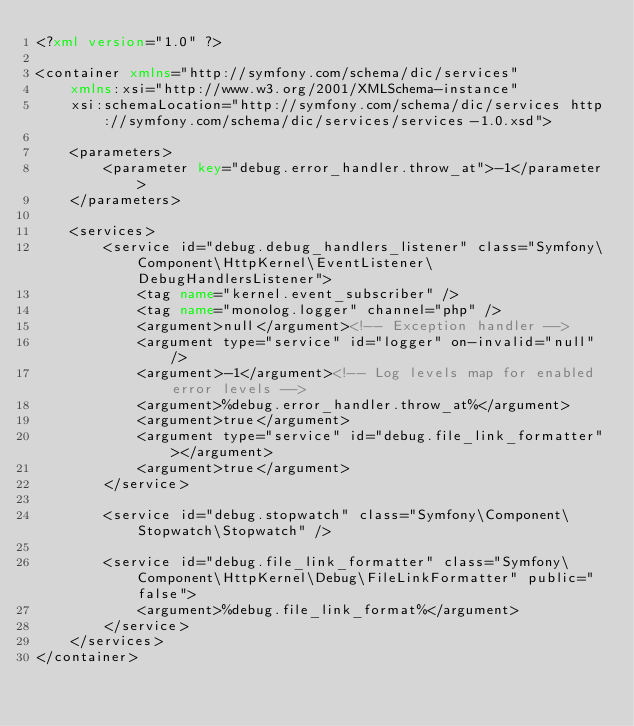<code> <loc_0><loc_0><loc_500><loc_500><_XML_><?xml version="1.0" ?>

<container xmlns="http://symfony.com/schema/dic/services"
    xmlns:xsi="http://www.w3.org/2001/XMLSchema-instance"
    xsi:schemaLocation="http://symfony.com/schema/dic/services http://symfony.com/schema/dic/services/services-1.0.xsd">

    <parameters>
        <parameter key="debug.error_handler.throw_at">-1</parameter>
    </parameters>

    <services>
        <service id="debug.debug_handlers_listener" class="Symfony\Component\HttpKernel\EventListener\DebugHandlersListener">
            <tag name="kernel.event_subscriber" />
            <tag name="monolog.logger" channel="php" />
            <argument>null</argument><!-- Exception handler -->
            <argument type="service" id="logger" on-invalid="null" />
            <argument>-1</argument><!-- Log levels map for enabled error levels -->
            <argument>%debug.error_handler.throw_at%</argument>
            <argument>true</argument>
            <argument type="service" id="debug.file_link_formatter"></argument>
            <argument>true</argument>
        </service>

        <service id="debug.stopwatch" class="Symfony\Component\Stopwatch\Stopwatch" />

        <service id="debug.file_link_formatter" class="Symfony\Component\HttpKernel\Debug\FileLinkFormatter" public="false">
            <argument>%debug.file_link_format%</argument>
        </service>
    </services>
</container>
</code> 